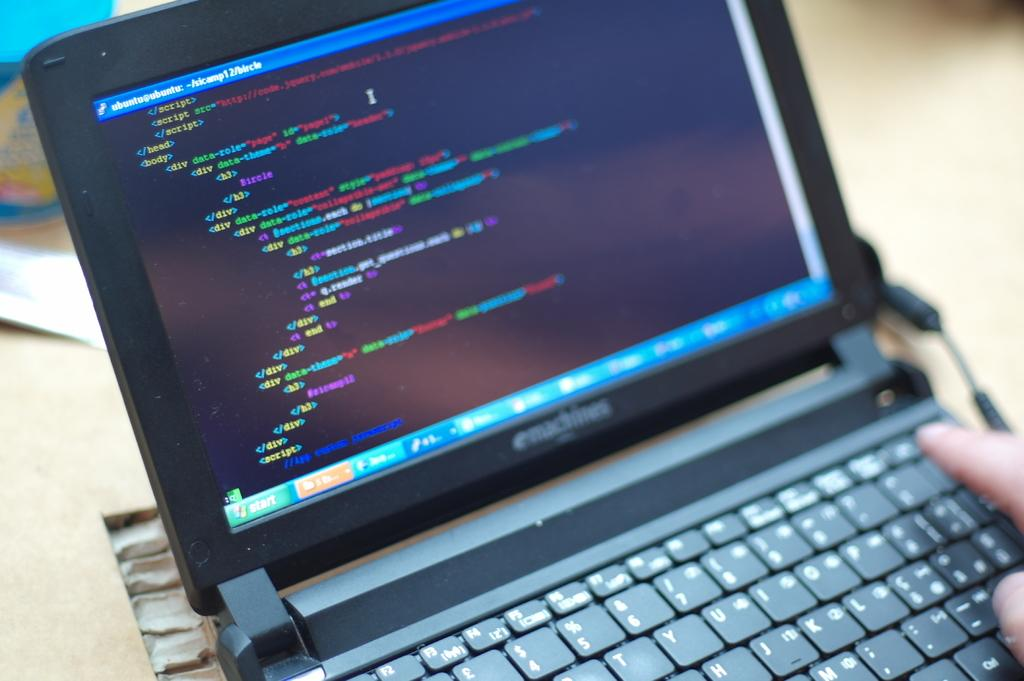<image>
Share a concise interpretation of the image provided. Person using a tiny eMachines laptop on a wooden table. 